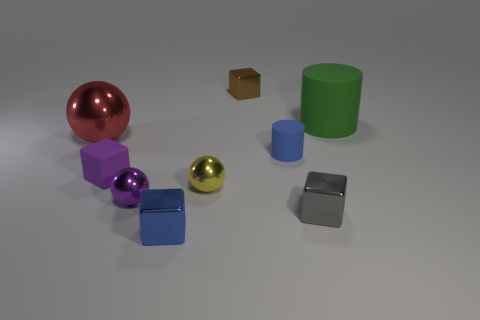There is a cube that is behind the red ball; what is it made of?
Your answer should be very brief. Metal. There is a metallic cube behind the large green matte thing; what number of purple objects are on the left side of it?
Offer a very short reply. 2. How many tiny brown metal things are the same shape as the small gray metal object?
Give a very brief answer. 1. What number of purple shiny cubes are there?
Keep it short and to the point. 0. What color is the small cube behind the big cylinder?
Offer a very short reply. Brown. There is a large thing that is to the left of the metal ball to the right of the blue metal block; what color is it?
Keep it short and to the point. Red. There is another matte thing that is the same size as the purple rubber object; what is its color?
Offer a very short reply. Blue. How many cubes are in front of the red thing and behind the large cylinder?
Your answer should be very brief. 0. What shape is the thing that is the same color as the small matte cylinder?
Provide a succinct answer. Cube. What is the cube that is both on the left side of the tiny brown metal thing and to the right of the small purple rubber cube made of?
Offer a very short reply. Metal. 